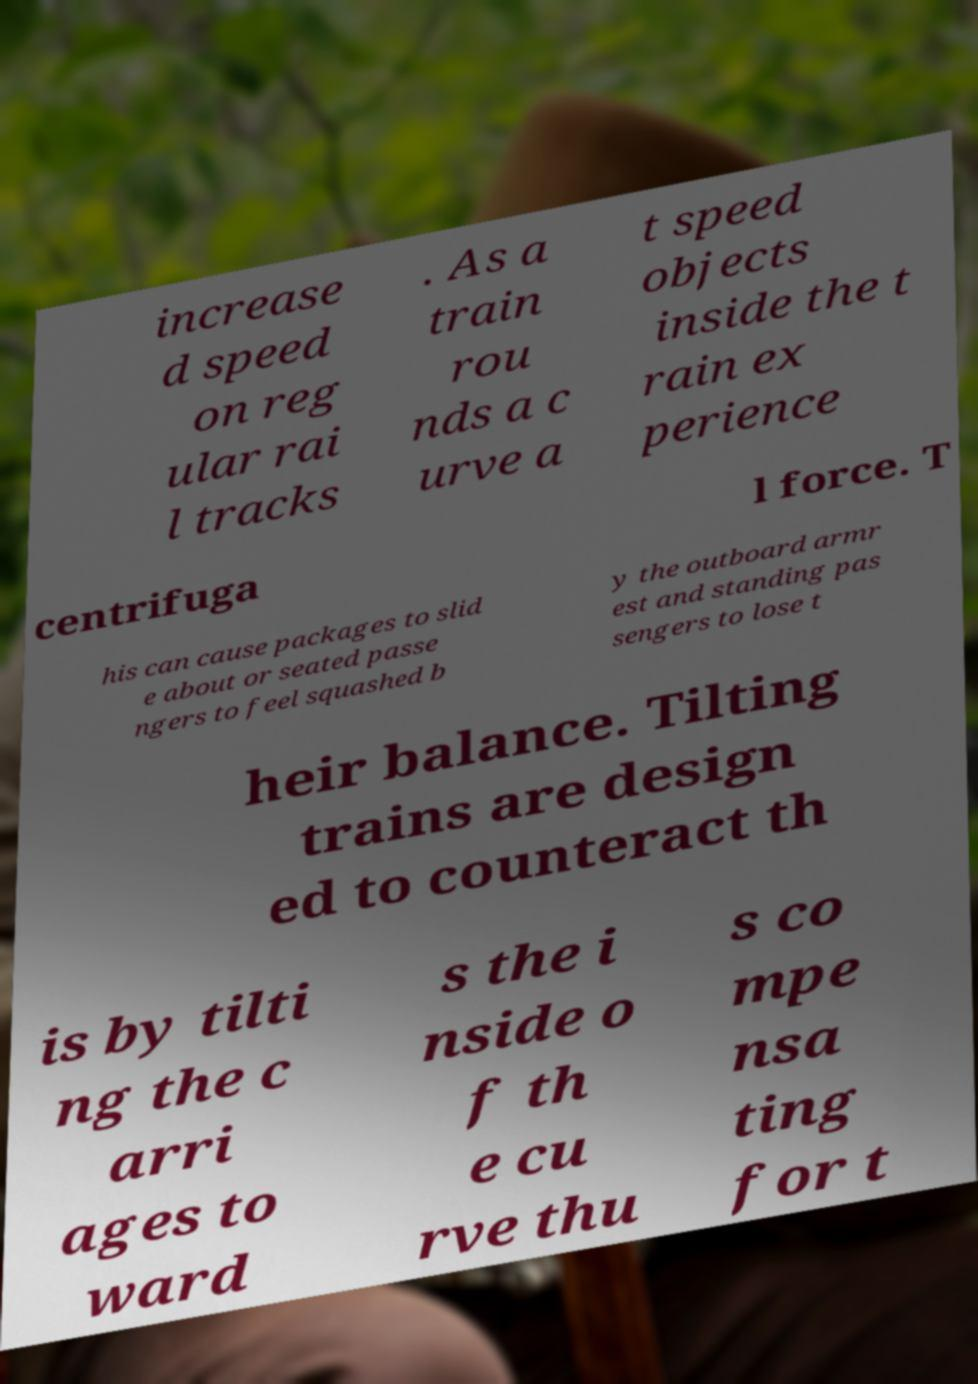For documentation purposes, I need the text within this image transcribed. Could you provide that? increase d speed on reg ular rai l tracks . As a train rou nds a c urve a t speed objects inside the t rain ex perience centrifuga l force. T his can cause packages to slid e about or seated passe ngers to feel squashed b y the outboard armr est and standing pas sengers to lose t heir balance. Tilting trains are design ed to counteract th is by tilti ng the c arri ages to ward s the i nside o f th e cu rve thu s co mpe nsa ting for t 